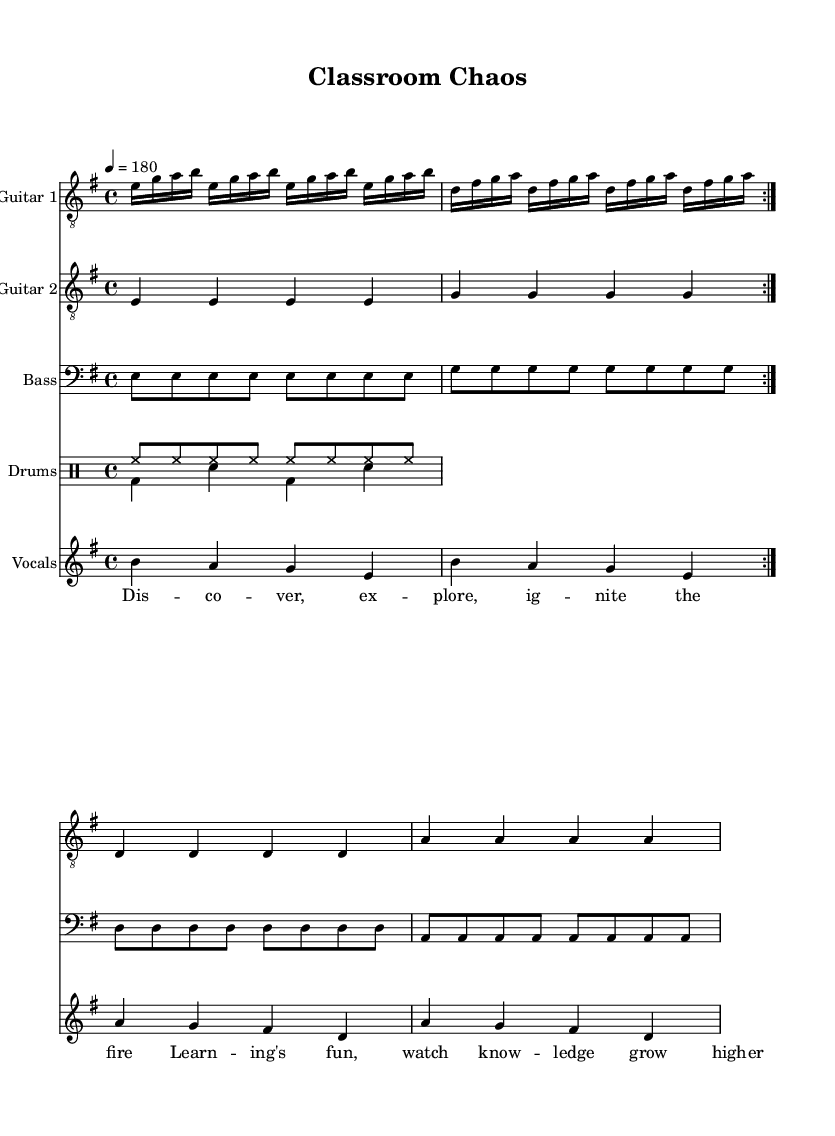What is the key signature of this music? The key signature is indicated by the presence of one sharp, which corresponds to E minor. Thus, the key signature for this piece is E minor.
Answer: E minor What is the time signature of this music? The time signature is typically located at the beginning of the staff and here it is depicted as 4/4, which means four beats per measure.
Answer: 4/4 What is the tempo marking for this piece? Time signatures often have a tempo marking beneath them. In this case, it is indicated as 4 = 180, suggesting the piece should be played at 180 beats per minute.
Answer: 180 How many times is the main guitar part repeated? The main guitar part (guitar one) is indicated with "volta 2", which suggests that the section is repeated twice.
Answer: 2 How many different instruments are indicated in this score? By examining the score, there are five distinct staves for different instruments: Guitar 1, Guitar 2, Bass, Drums, and Vocals. Therefore, there are five different instruments present.
Answer: 5 What is the lyrical theme of the chorus? The lyrics convey a theme of discovery and exploration, focusing on the excitement of learning and knowledge growth, emphasized by phrases like "ignite the fire".
Answer: Discovery 